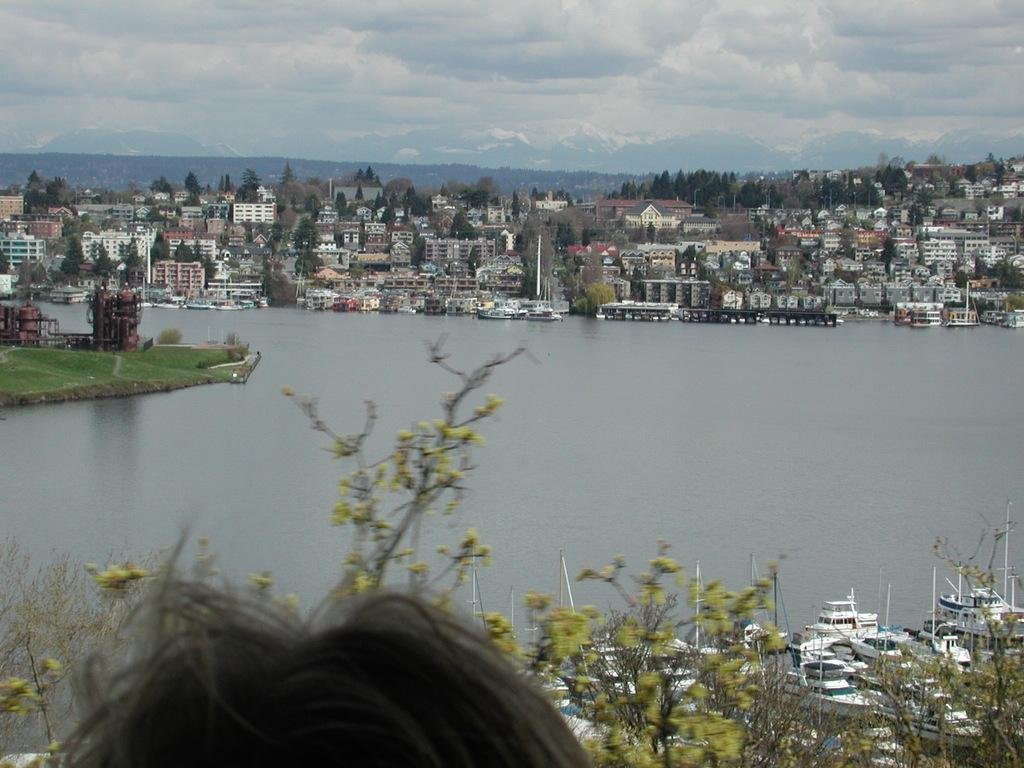What is on the water in the image? There are boats on the water in the image. What else can be seen in the image besides the boats? There are buildings and trees visible in the image. What is visible in the background of the image? The sky is visible in the background of the image. Can you tell me how many clams are on the trees in the image? There are no clams present in the image; it features boats on the water, buildings, trees, and the sky. What type of rock is being used to copy the boats in the image? There is no rock or copying activity present in the image. 